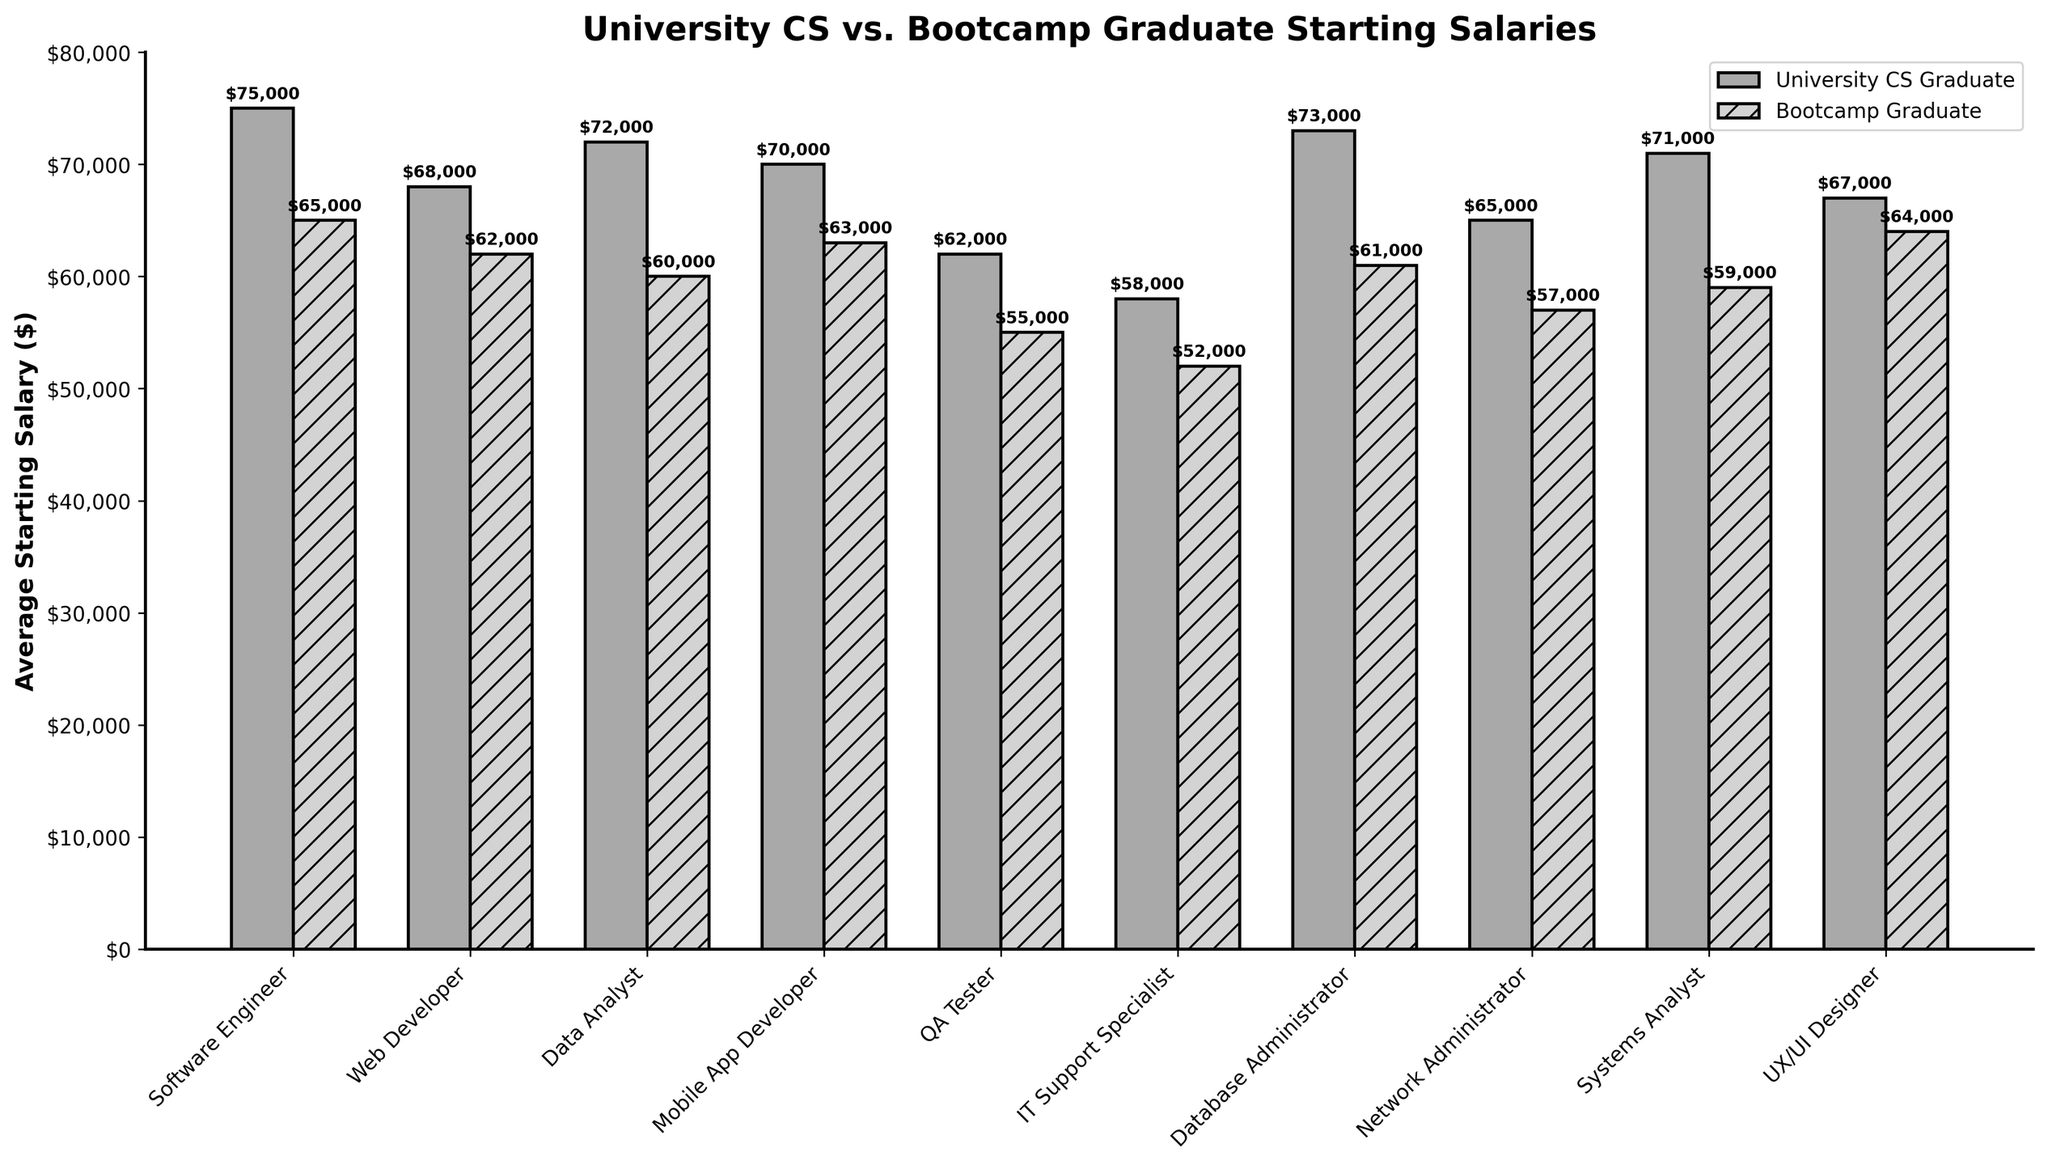What's the highest starting salary for bootcamp graduates? The highest bar for bootcamp graduates is for UX/UI Designers at $64,000, which is visibly the tallest bar among the bootcamp positions.
Answer: $64,000 Which position shows the greatest difference in starting salaries between university CS graduates and bootcamp graduates? The bar chart shows that QA Tester has a significant difference, with university CS graduates earning $62,000 and bootcamp graduates earning $55,000, resulting in a difference of $7,000.
Answer: QA Tester What's the average starting salary for university CS graduates across all positions? Sum the starting salaries for all university CS graduates ($75,000 + $68,000 + $72,000 + $70,000 + $62,000 + $58,000 + $73,000 + $65,000 + $71,000 + $67,000) = $681,000. Divide by the number of positions (10). $681,000 / 10 = $68,100.
Answer: $68,100 Compare the average starting salary for bootcamp graduates to that of university CS graduates. First, calculate the total of starting salaries for bootcamp graduates: ($65,000 + $62,000 + $60,000 + $63,000 + $55,000 + $52,000 + $61,000 + $57,000 + $59,000 + $64,000) = $598,000. Next, divide by 10 (positions) to get the average: $598,000 / 10 = $59,800. The university CS graduates' average is $68,100.
Answer: $59,800 vs $68,100 For which positions are the salaries of university CS graduates closest to bootcamp graduates? The positions closest in salary difference are UX/UI Designer, where university CS graduates earn $67,000 and bootcamp graduates earn $64,000, making a difference of $3,000.
Answer: UX/UI Designer Which type of graduate has the highest starting salary overall? The university CS graduate has the highest starting salary for the position of Software Engineer at $75,000.
Answer: University CS Graduate Identify the position that shows the largest salary disparity in favor of university CS graduates. This is the Software Engineer position, where university CS graduates earn $75,000 compared to $65,000 for bootcamp graduates, a disparity of $10,000.
Answer: Software Engineer How many positions have starting salaries for university CS graduates above $70,000? By examining the bar heights, Software Engineer, Data Analyst, Database Administrator, and Systems Analyst all have salaries above $70,000.
Answer: 4 Which positions have starting salaries below $60,000 for bootcamp graduates? Bootcamp graduates have starting salaries below $60,000 for QA Tester ($55,000), IT Support Specialist ($52,000), and Network Administrator ($57,000).
Answer: 3 What's the difference in average starting salaries between university CS graduates and bootcamp graduates? The average for university CS graduates is $68,100, and for bootcamp graduates it is $59,800. The difference is $68,100 - $59,800 = $8,300.
Answer: $8,300 